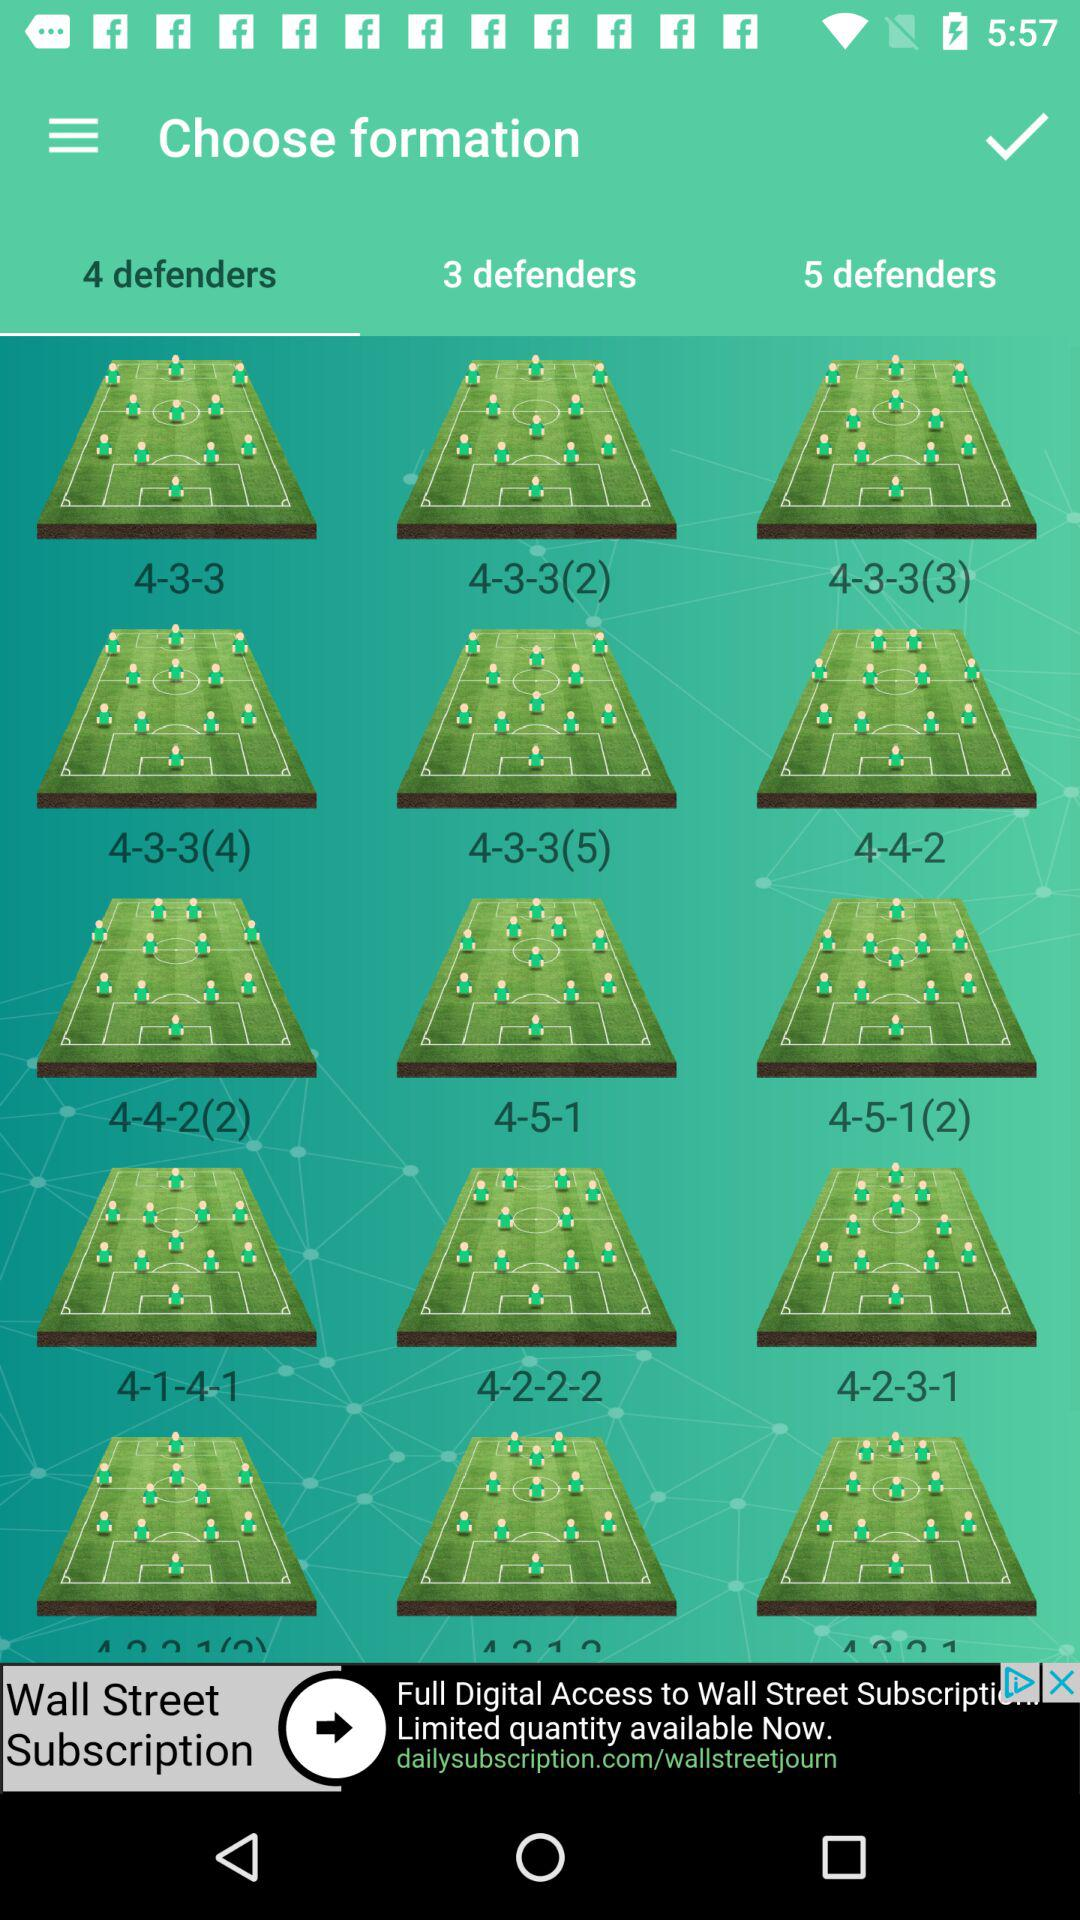What is the selected tab? The selected tab is "4 defenders". 